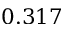Convert formula to latex. <formula><loc_0><loc_0><loc_500><loc_500>0 . 3 1 7</formula> 